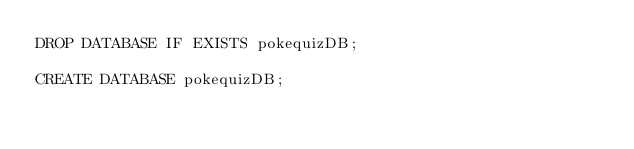<code> <loc_0><loc_0><loc_500><loc_500><_SQL_>DROP DATABASE IF EXISTS pokequizDB;

CREATE DATABASE pokequizDB;
</code> 